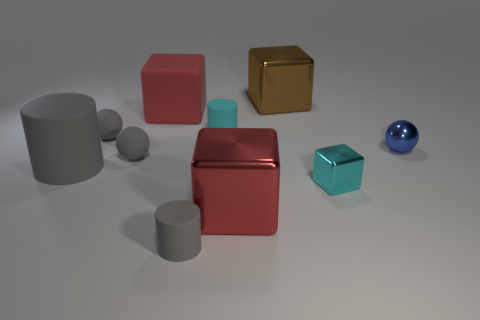What number of things are small cyan matte objects or small green cylinders?
Provide a short and direct response. 1. Is the shape of the big brown metal object the same as the tiny cyan metallic object?
Offer a very short reply. Yes. Is there a block that has the same material as the tiny gray cylinder?
Offer a very short reply. Yes. Are there any big red shiny blocks that are to the left of the big block in front of the small blue shiny ball?
Offer a terse response. No. There is a gray rubber thing right of the red matte cube; is it the same size as the big brown thing?
Provide a succinct answer. No. The blue ball has what size?
Provide a succinct answer. Small. Are there any objects of the same color as the rubber block?
Provide a short and direct response. Yes. What number of small objects are either cyan cylinders or cylinders?
Your answer should be very brief. 2. There is a metallic thing that is both behind the small cyan shiny thing and left of the blue ball; what is its size?
Offer a very short reply. Large. There is a large red rubber object; how many blue balls are in front of it?
Your response must be concise. 1. 